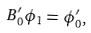<formula> <loc_0><loc_0><loc_500><loc_500>B _ { 0 } ^ { \prime } \phi _ { 1 } = \phi _ { 0 } ^ { \prime } ,</formula> 